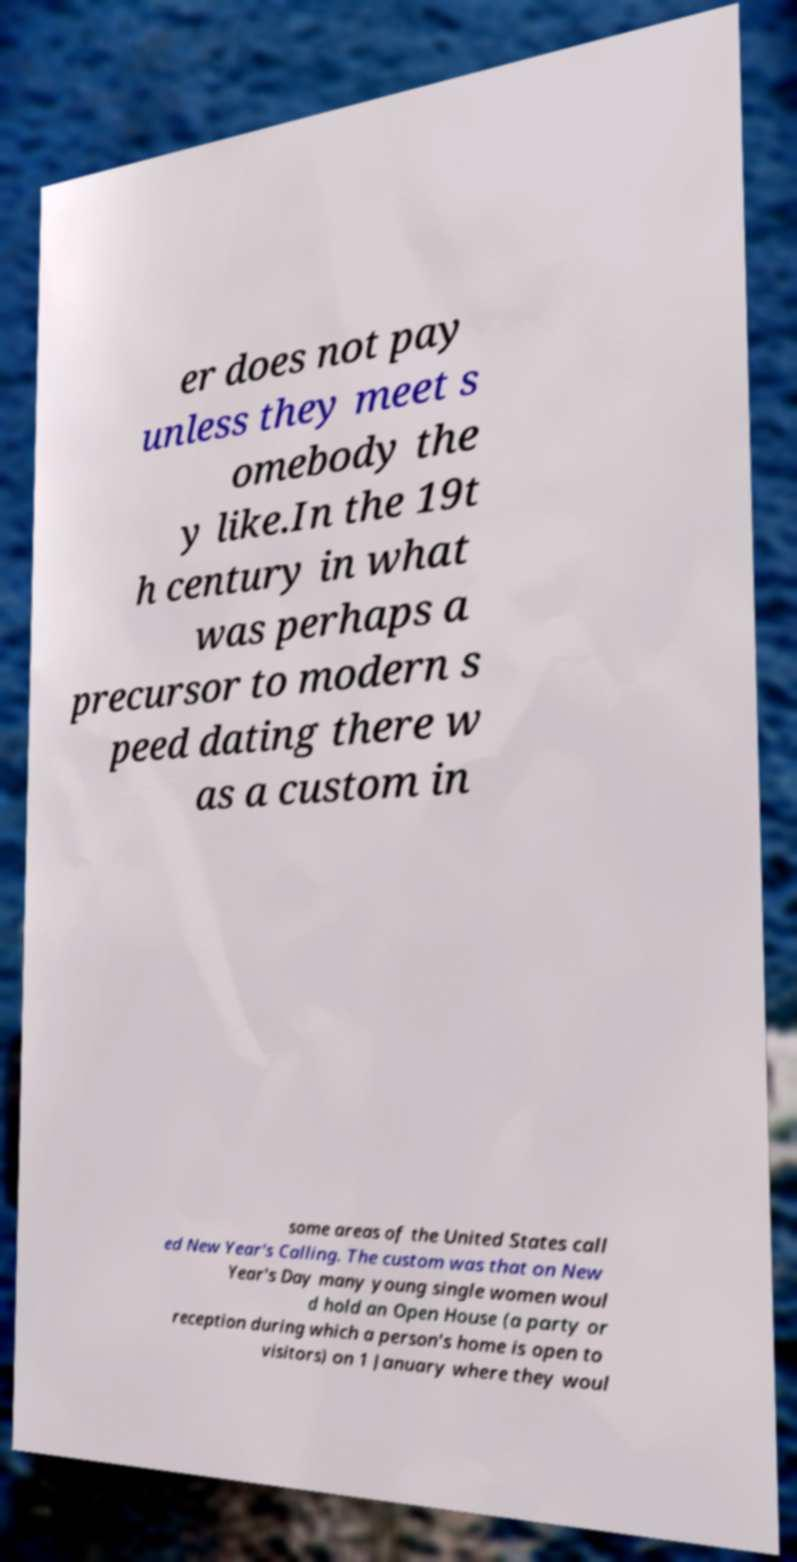There's text embedded in this image that I need extracted. Can you transcribe it verbatim? er does not pay unless they meet s omebody the y like.In the 19t h century in what was perhaps a precursor to modern s peed dating there w as a custom in some areas of the United States call ed New Year's Calling. The custom was that on New Year's Day many young single women woul d hold an Open House (a party or reception during which a person's home is open to visitors) on 1 January where they woul 